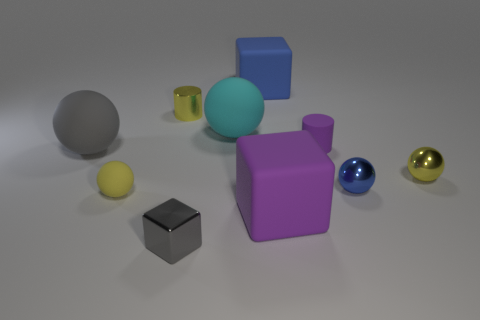Are there any large purple blocks on the left side of the tiny blue thing?
Make the answer very short. Yes. What number of other things are there of the same shape as the tiny blue shiny object?
Your answer should be very brief. 4. There is a cube that is the same size as the yellow cylinder; what color is it?
Give a very brief answer. Gray. Are there fewer small shiny cylinders that are right of the big cyan object than large blue things that are to the right of the purple block?
Provide a succinct answer. No. What number of blue objects are in front of the blue object that is behind the small cylinder on the left side of the big blue matte cube?
Provide a short and direct response. 1. There is a yellow metallic object that is the same shape as the big cyan thing; what is its size?
Provide a succinct answer. Small. Are there any other things that are the same size as the blue matte cube?
Keep it short and to the point. Yes. Is the number of gray things in front of the tiny yellow shiny sphere less than the number of cyan things?
Give a very brief answer. No. Is the tiny gray metal object the same shape as the gray rubber thing?
Your answer should be very brief. No. The other big thing that is the same shape as the cyan object is what color?
Make the answer very short. Gray. 